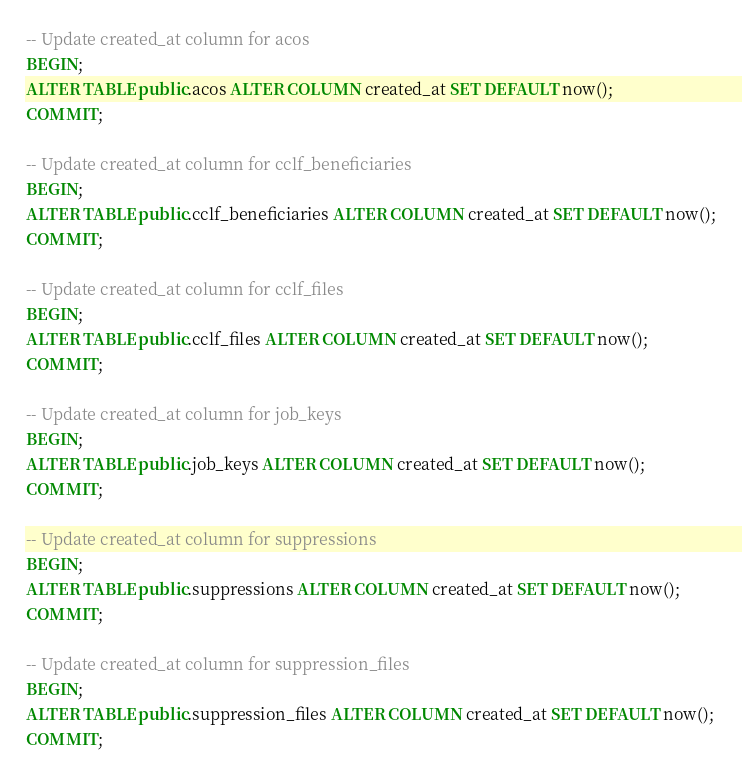<code> <loc_0><loc_0><loc_500><loc_500><_SQL_>-- Update created_at column for acos
BEGIN;
ALTER TABLE public.acos ALTER COLUMN created_at SET DEFAULT now();
COMMIT;

-- Update created_at column for cclf_beneficiaries
BEGIN;
ALTER TABLE public.cclf_beneficiaries ALTER COLUMN created_at SET DEFAULT now();
COMMIT;

-- Update created_at column for cclf_files
BEGIN;
ALTER TABLE public.cclf_files ALTER COLUMN created_at SET DEFAULT now();
COMMIT;

-- Update created_at column for job_keys
BEGIN;
ALTER TABLE public.job_keys ALTER COLUMN created_at SET DEFAULT now();
COMMIT;

-- Update created_at column for suppressions
BEGIN;
ALTER TABLE public.suppressions ALTER COLUMN created_at SET DEFAULT now();
COMMIT;

-- Update created_at column for suppression_files
BEGIN;
ALTER TABLE public.suppression_files ALTER COLUMN created_at SET DEFAULT now();
COMMIT;</code> 